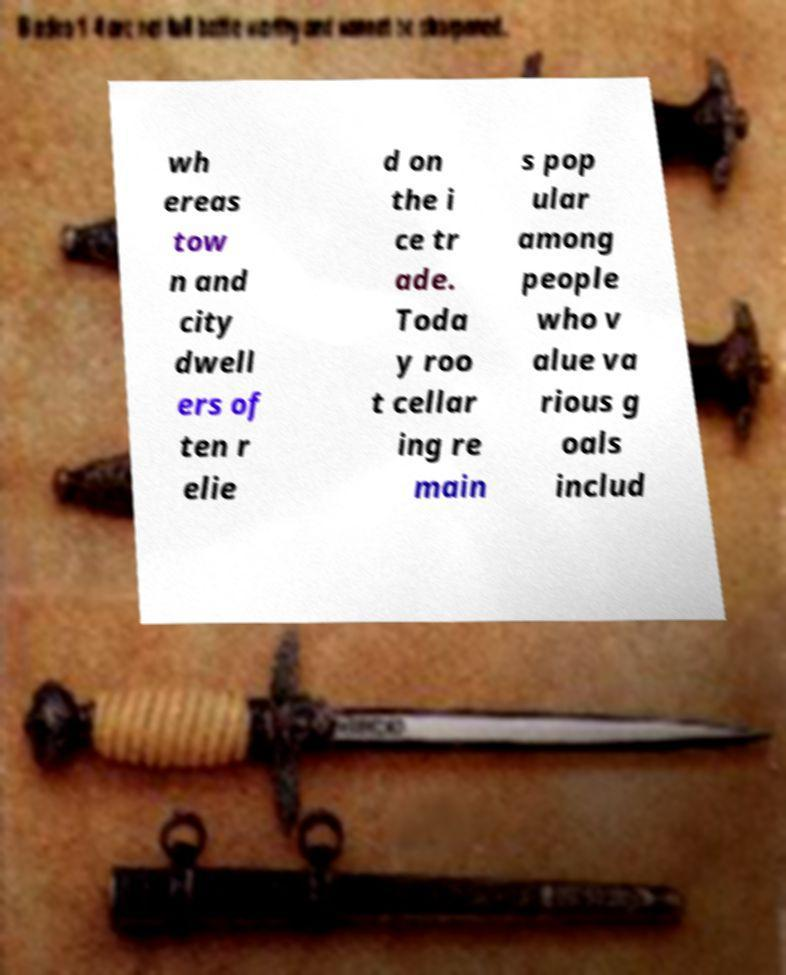Can you accurately transcribe the text from the provided image for me? wh ereas tow n and city dwell ers of ten r elie d on the i ce tr ade. Toda y roo t cellar ing re main s pop ular among people who v alue va rious g oals includ 